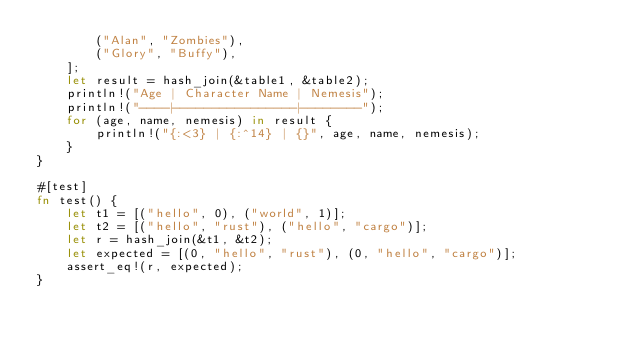Convert code to text. <code><loc_0><loc_0><loc_500><loc_500><_Rust_>        ("Alan", "Zombies"),
        ("Glory", "Buffy"),
    ];
    let result = hash_join(&table1, &table2);
    println!("Age | Character Name | Nemesis");
    println!("----|----------------|--------");
    for (age, name, nemesis) in result {
        println!("{:<3} | {:^14} | {}", age, name, nemesis);
    }
}

#[test]
fn test() {
    let t1 = [("hello", 0), ("world", 1)];
    let t2 = [("hello", "rust"), ("hello", "cargo")];
    let r = hash_join(&t1, &t2);
    let expected = [(0, "hello", "rust"), (0, "hello", "cargo")];
    assert_eq!(r, expected);
}
</code> 